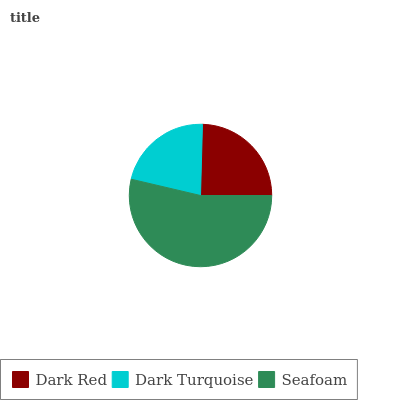Is Dark Turquoise the minimum?
Answer yes or no. Yes. Is Seafoam the maximum?
Answer yes or no. Yes. Is Seafoam the minimum?
Answer yes or no. No. Is Dark Turquoise the maximum?
Answer yes or no. No. Is Seafoam greater than Dark Turquoise?
Answer yes or no. Yes. Is Dark Turquoise less than Seafoam?
Answer yes or no. Yes. Is Dark Turquoise greater than Seafoam?
Answer yes or no. No. Is Seafoam less than Dark Turquoise?
Answer yes or no. No. Is Dark Red the high median?
Answer yes or no. Yes. Is Dark Red the low median?
Answer yes or no. Yes. Is Seafoam the high median?
Answer yes or no. No. Is Dark Turquoise the low median?
Answer yes or no. No. 